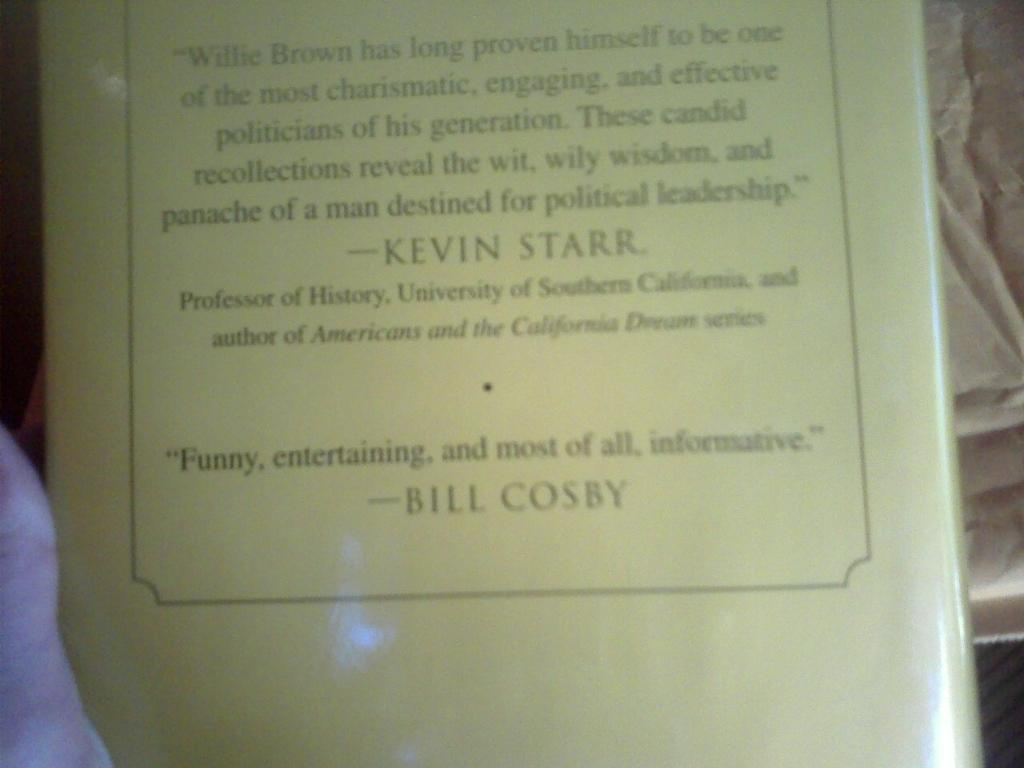What is the main object in the middle of the image? There is a book in the middle of the image. What color and type of material is present in the left side corner of the image? There is a pink color cloth in the left side corner of the image. What color is visible on the right side of the image? There is a cream color visible on the right side of the image. How many steps are required to complete the work shown in the image? There is no work or steps present in the image; it only features a book, a pink cloth, and a cream color. 